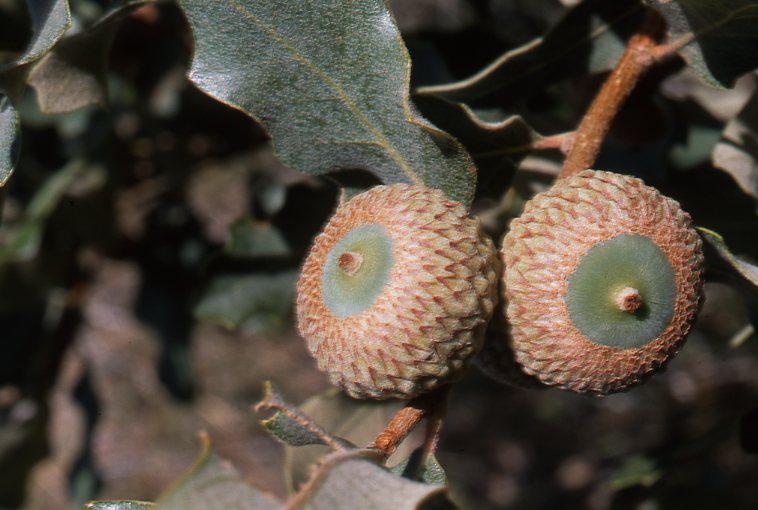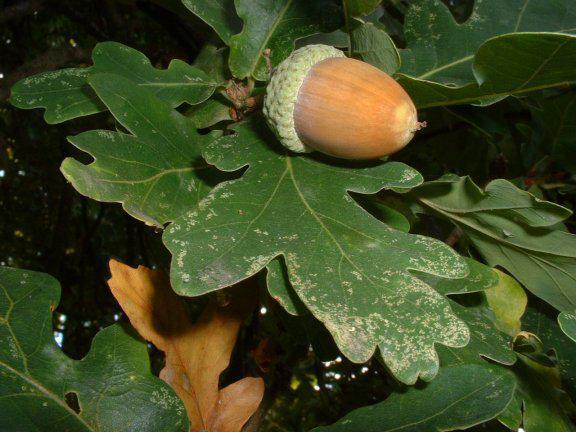The first image is the image on the left, the second image is the image on the right. Assess this claim about the two images: "There are two green acorns and green acorn tops still attach to there branch.". Correct or not? Answer yes or no. No. The first image is the image on the left, the second image is the image on the right. Examine the images to the left and right. Is the description "One image includes at least one brown acorn, and the other image features acorns that haven't fully emerged from their caps." accurate? Answer yes or no. Yes. 